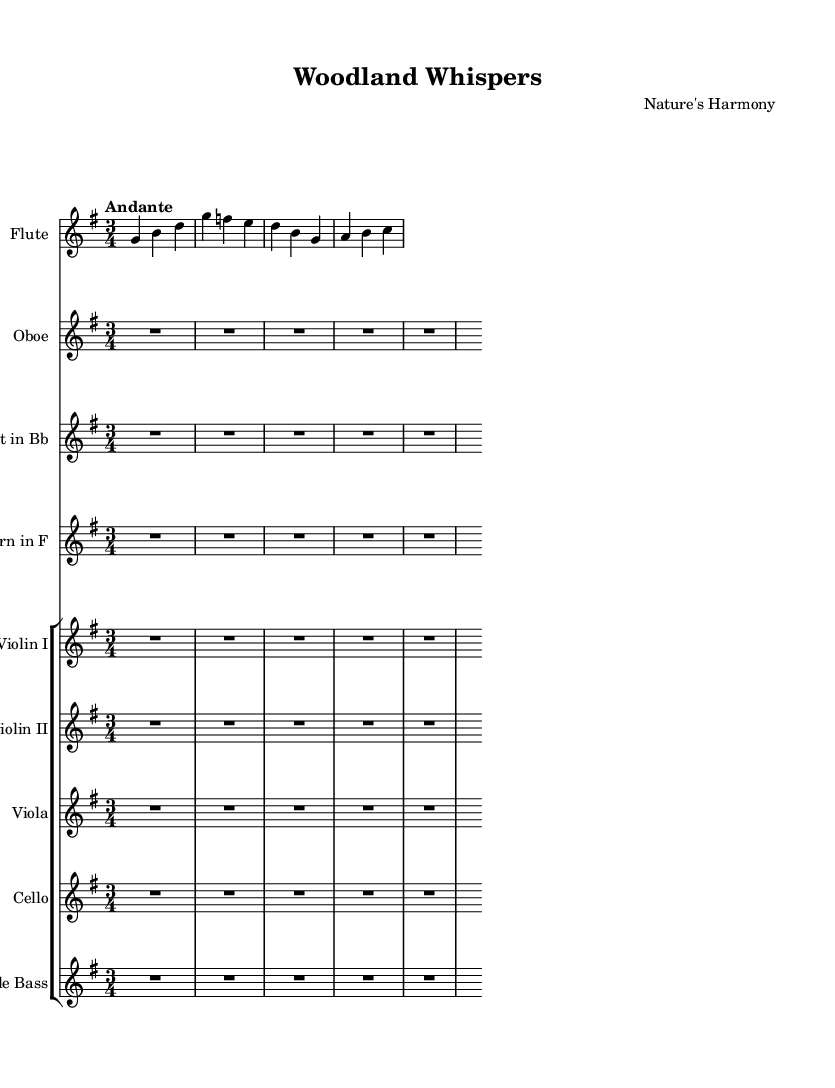What is the key signature of this music? The key signature indicates that the piece is in G major, which has one sharp. This can be determined by looking at the key signature indicated at the beginning of the score.
Answer: G major What is the time signature of this music? The time signature is represented at the beginning of the sheet music, which shows that it is in a 3/4 time signature. This means there are three beats per measure, and the quarter note gets one beat.
Answer: 3/4 What is the tempo marking for this piece? The tempo marking "Andante" is clearly indicated in the sheet music, describing the intended speed of the piece as moderately slow.
Answer: Andante How many instruments are in this composition? By counting each staff, we can see there are eight staves in total, which indicates that eight different instruments are featured in the composition.
Answer: Eight What is the highest pitch instrument in this piece? The flute is listed as the first instrument and typically has the highest range compared to the other instruments present in the piece, confirming it as the highest pitch instrument here.
Answer: Flute What is the role of the oboe in this composition? The oboe staff indicates that the instrument has rests (R1*4) throughout, suggesting it does not play in this excerpt, which points to the role being silent or merely supportive.
Answer: Rest Are there any string instruments shown in the score? The score distinctly lists multiple string instruments: Violin I, Violin II, Viola, Cello, and Double Bass, indicating that there are indeed string instruments present.
Answer: Yes 